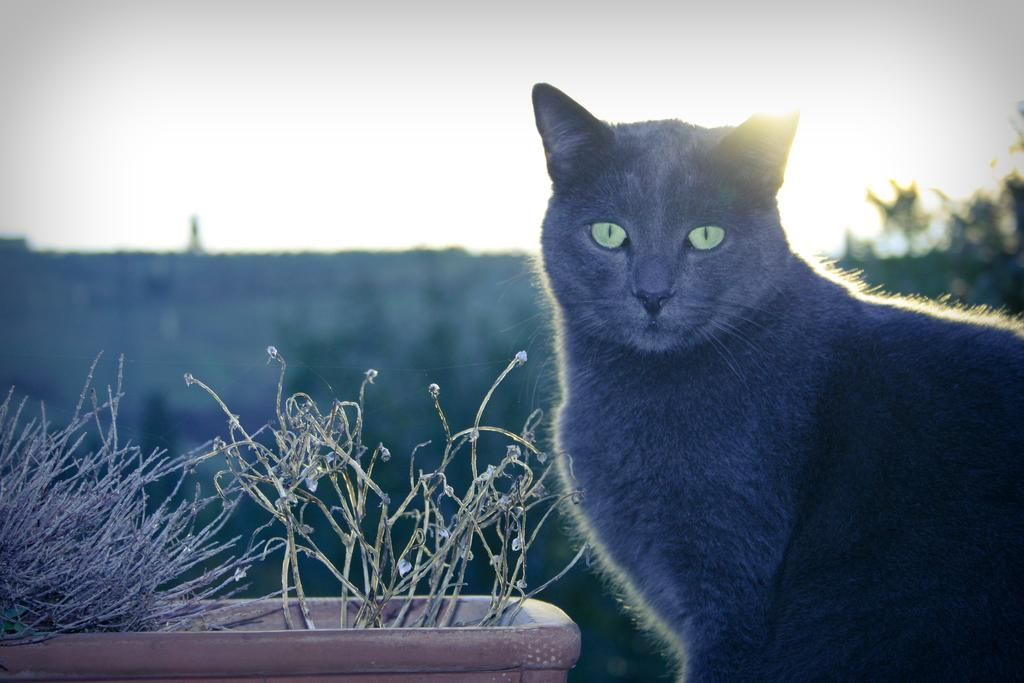What type of animal is present in the image? There is a cat in the image. What other living organisms can be seen in the image? There are plants and trees in the image. How would you describe the background of the image? The background of the image is blurred. What type of vest is the cat wearing in the image? There is no vest present on the cat in the image. Can you describe the game that the cat is playing with the plants in the image? There is no game or interaction between the cat and the plants in the image. 